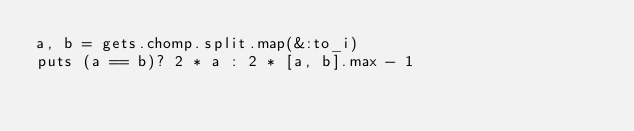Convert code to text. <code><loc_0><loc_0><loc_500><loc_500><_Ruby_>a, b = gets.chomp.split.map(&:to_i)
puts (a == b)? 2 * a : 2 * [a, b].max - 1</code> 